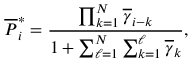<formula> <loc_0><loc_0><loc_500><loc_500>\overline { P } _ { i } ^ { * } = \frac { \prod _ { k = 1 } ^ { N } \overline { \gamma } _ { i - k } } { 1 + \sum _ { \ell = 1 } ^ { N } \sum _ { k = 1 } ^ { \ell } \overline { \gamma } _ { k } } ,</formula> 